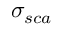<formula> <loc_0><loc_0><loc_500><loc_500>\sigma _ { s c a }</formula> 